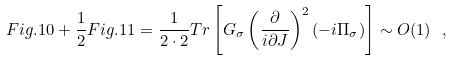<formula> <loc_0><loc_0><loc_500><loc_500>F i g . 1 0 + \frac { 1 } { 2 } F i g . 1 1 = \frac { 1 } { 2 \cdot 2 } T r \left [ G _ { \sigma } \left ( \frac { \partial } { i \partial J } \right ) ^ { 2 } ( - i \Pi _ { \sigma } ) \right ] \sim O ( 1 ) \ ,</formula> 